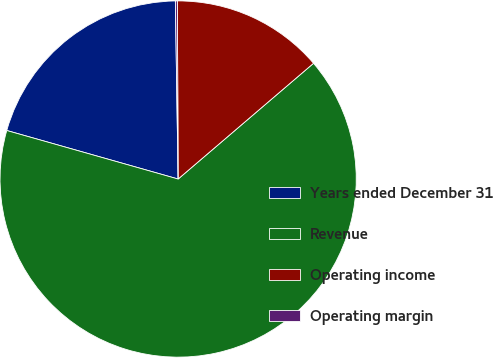Convert chart to OTSL. <chart><loc_0><loc_0><loc_500><loc_500><pie_chart><fcel>Years ended December 31<fcel>Revenue<fcel>Operating income<fcel>Operating margin<nl><fcel>20.36%<fcel>65.65%<fcel>13.81%<fcel>0.18%<nl></chart> 